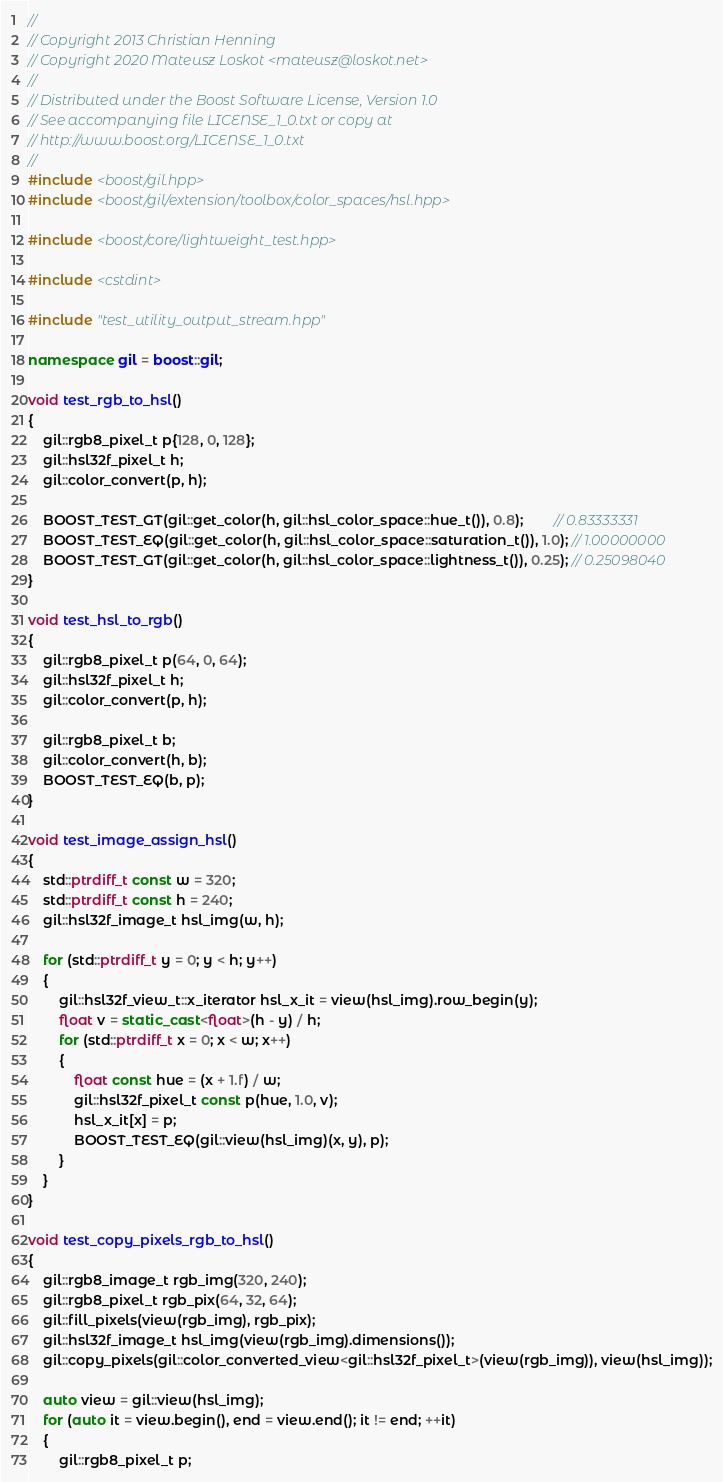Convert code to text. <code><loc_0><loc_0><loc_500><loc_500><_C++_>//
// Copyright 2013 Christian Henning
// Copyright 2020 Mateusz Loskot <mateusz@loskot.net>
//
// Distributed under the Boost Software License, Version 1.0
// See accompanying file LICENSE_1_0.txt or copy at
// http://www.boost.org/LICENSE_1_0.txt
//
#include <boost/gil.hpp>
#include <boost/gil/extension/toolbox/color_spaces/hsl.hpp>

#include <boost/core/lightweight_test.hpp>

#include <cstdint>

#include "test_utility_output_stream.hpp"

namespace gil = boost::gil;

void test_rgb_to_hsl()
{
    gil::rgb8_pixel_t p{128, 0, 128};
    gil::hsl32f_pixel_t h;
    gil::color_convert(p, h);

    BOOST_TEST_GT(gil::get_color(h, gil::hsl_color_space::hue_t()), 0.8);        // 0.83333331
    BOOST_TEST_EQ(gil::get_color(h, gil::hsl_color_space::saturation_t()), 1.0); // 1.00000000
    BOOST_TEST_GT(gil::get_color(h, gil::hsl_color_space::lightness_t()), 0.25); // 0.25098040
}

void test_hsl_to_rgb()
{
    gil::rgb8_pixel_t p(64, 0, 64);
    gil::hsl32f_pixel_t h;
    gil::color_convert(p, h);

    gil::rgb8_pixel_t b;
    gil::color_convert(h, b);
    BOOST_TEST_EQ(b, p);
}

void test_image_assign_hsl()
{
    std::ptrdiff_t const w = 320;
    std::ptrdiff_t const h = 240;
    gil::hsl32f_image_t hsl_img(w, h);

    for (std::ptrdiff_t y = 0; y < h; y++)
    {
        gil::hsl32f_view_t::x_iterator hsl_x_it = view(hsl_img).row_begin(y);
        float v = static_cast<float>(h - y) / h;
        for (std::ptrdiff_t x = 0; x < w; x++)
        {
            float const hue = (x + 1.f) / w;
            gil::hsl32f_pixel_t const p(hue, 1.0, v);
            hsl_x_it[x] = p;
            BOOST_TEST_EQ(gil::view(hsl_img)(x, y), p);
        }
    }
}

void test_copy_pixels_rgb_to_hsl()
{
    gil::rgb8_image_t rgb_img(320, 240);
    gil::rgb8_pixel_t rgb_pix(64, 32, 64);
    gil::fill_pixels(view(rgb_img), rgb_pix);
    gil::hsl32f_image_t hsl_img(view(rgb_img).dimensions());
    gil::copy_pixels(gil::color_converted_view<gil::hsl32f_pixel_t>(view(rgb_img)), view(hsl_img));

    auto view = gil::view(hsl_img);
    for (auto it = view.begin(), end = view.end(); it != end; ++it)
    {
        gil::rgb8_pixel_t p;</code> 